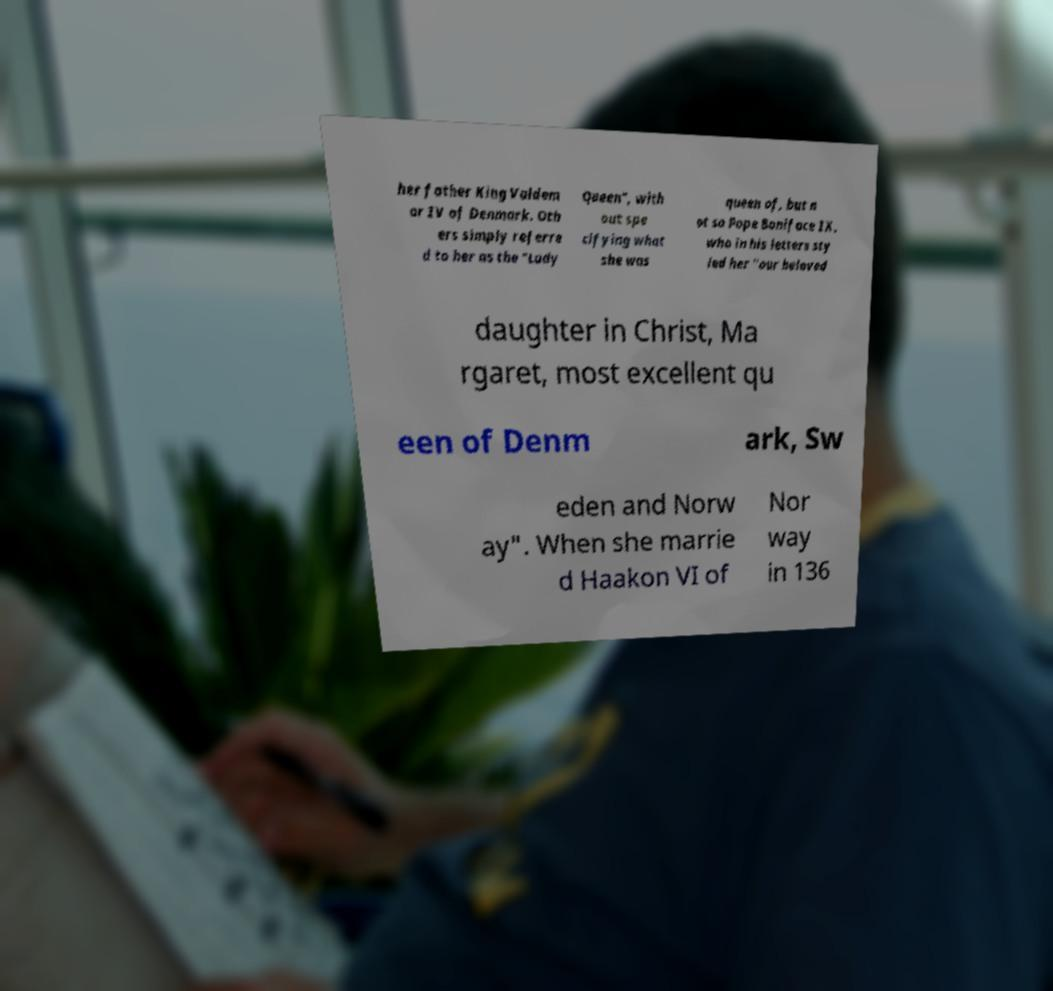Please read and relay the text visible in this image. What does it say? her father King Valdem ar IV of Denmark. Oth ers simply referre d to her as the "Lady Queen", with out spe cifying what she was queen of, but n ot so Pope Boniface IX, who in his letters sty led her "our beloved daughter in Christ, Ma rgaret, most excellent qu een of Denm ark, Sw eden and Norw ay". When she marrie d Haakon VI of Nor way in 136 